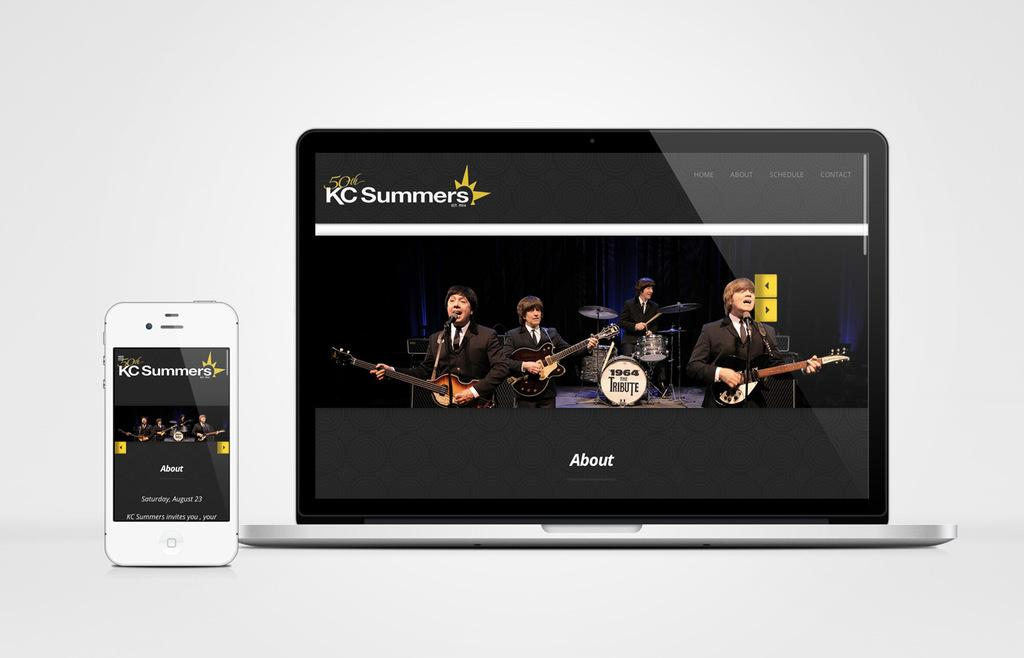<image>
Write a terse but informative summary of the picture. A smartphone and laptop next to each other advertising 50th KC Summers 